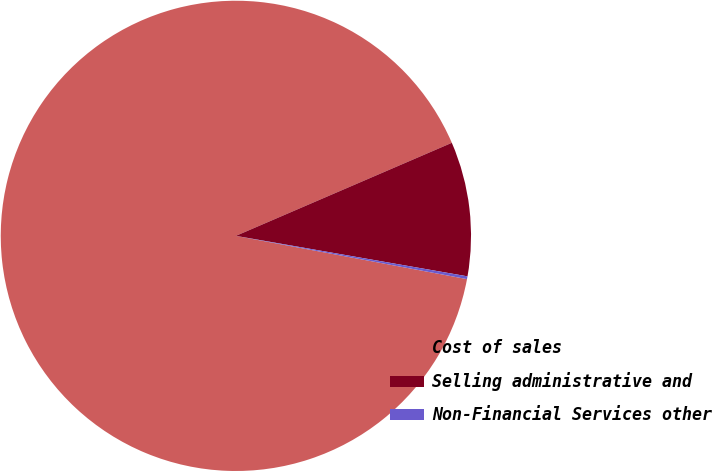Convert chart to OTSL. <chart><loc_0><loc_0><loc_500><loc_500><pie_chart><fcel>Cost of sales<fcel>Selling administrative and<fcel>Non-Financial Services other<nl><fcel>90.58%<fcel>9.23%<fcel>0.19%<nl></chart> 